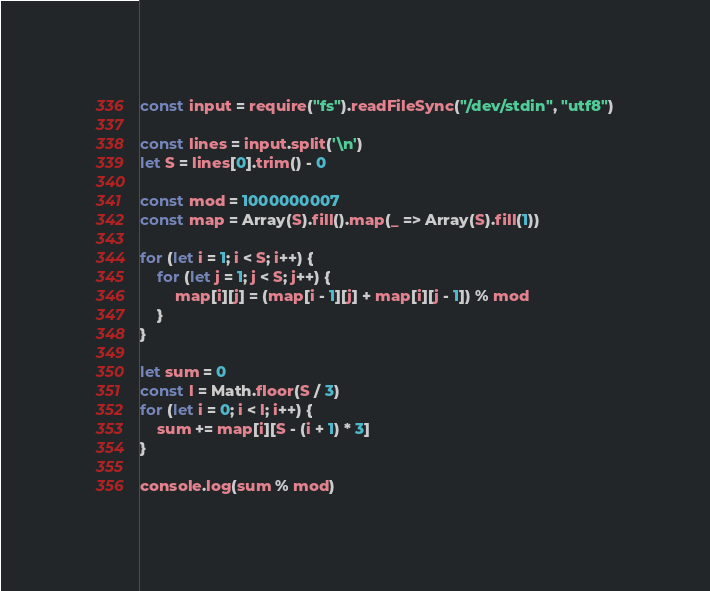Convert code to text. <code><loc_0><loc_0><loc_500><loc_500><_JavaScript_>const input = require("fs").readFileSync("/dev/stdin", "utf8")

const lines = input.split('\n')
let S = lines[0].trim() - 0

const mod = 1000000007
const map = Array(S).fill().map(_ => Array(S).fill(1))

for (let i = 1; i < S; i++) {
    for (let j = 1; j < S; j++) {
        map[i][j] = (map[i - 1][j] + map[i][j - 1]) % mod
    }
}

let sum = 0
const l = Math.floor(S / 3)
for (let i = 0; i < l; i++) {
    sum += map[i][S - (i + 1) * 3]
}

console.log(sum % mod)
</code> 